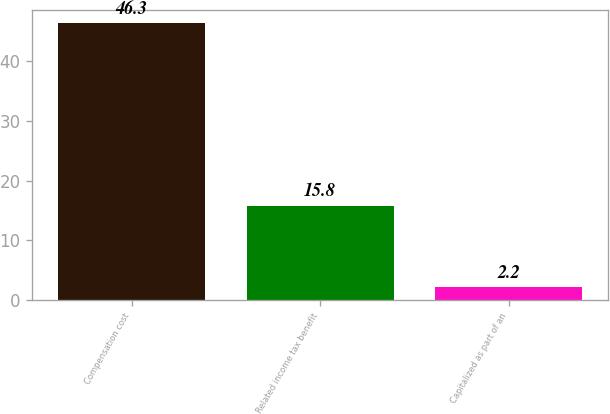Convert chart. <chart><loc_0><loc_0><loc_500><loc_500><bar_chart><fcel>Compensation cost<fcel>Related income tax benefit<fcel>Capitalized as part of an<nl><fcel>46.3<fcel>15.8<fcel>2.2<nl></chart> 